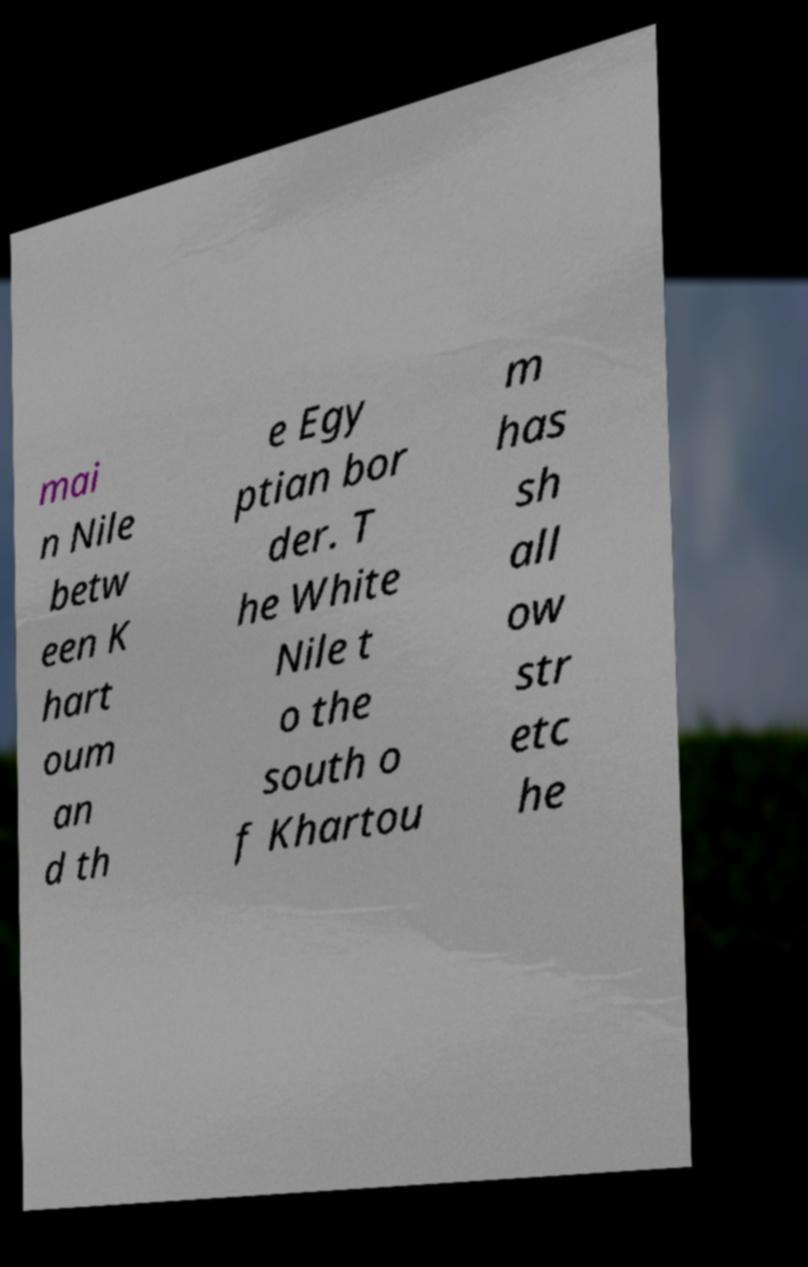Can you accurately transcribe the text from the provided image for me? mai n Nile betw een K hart oum an d th e Egy ptian bor der. T he White Nile t o the south o f Khartou m has sh all ow str etc he 